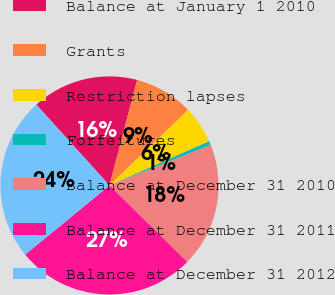Convert chart. <chart><loc_0><loc_0><loc_500><loc_500><pie_chart><fcel>Balance at January 1 2010<fcel>Grants<fcel>Restriction lapses<fcel>Forfeitures<fcel>Balance at December 31 2010<fcel>Balance at December 31 2011<fcel>Balance at December 31 2012<nl><fcel>15.79%<fcel>8.74%<fcel>5.53%<fcel>0.58%<fcel>18.43%<fcel>26.7%<fcel>24.22%<nl></chart> 